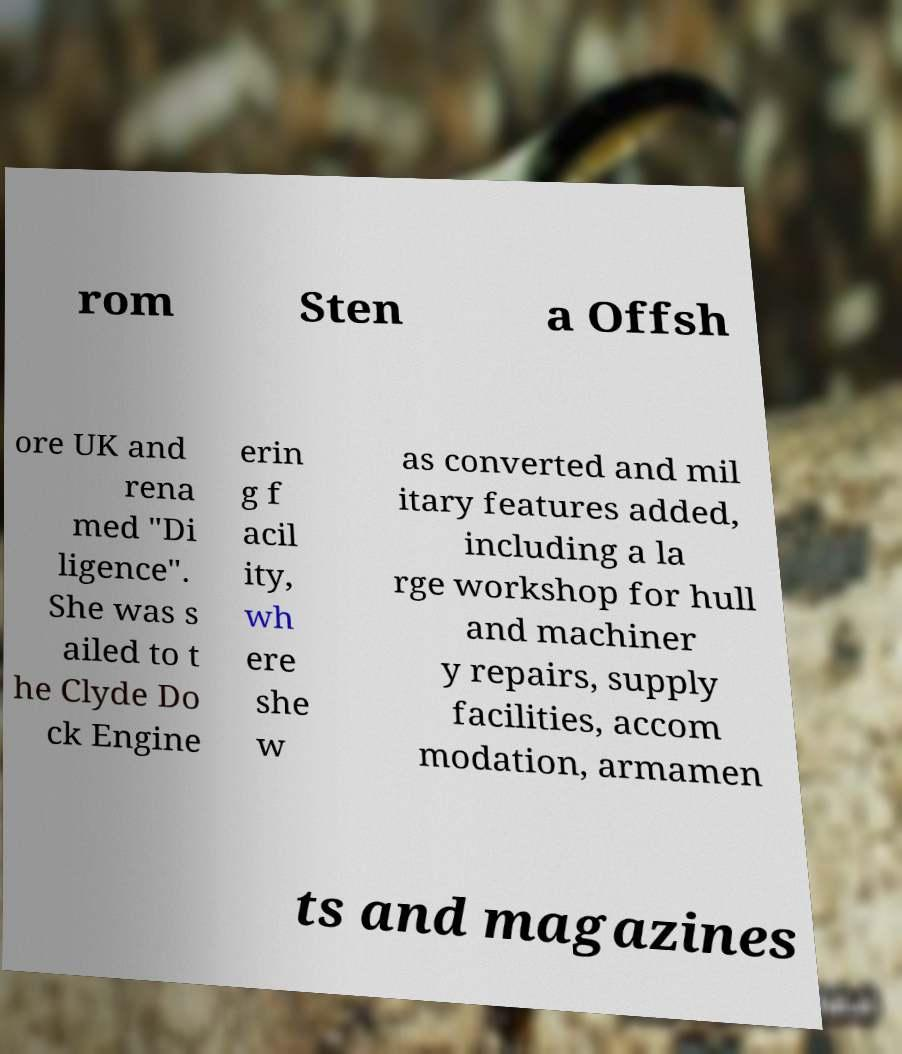Could you assist in decoding the text presented in this image and type it out clearly? rom Sten a Offsh ore UK and rena med "Di ligence". She was s ailed to t he Clyde Do ck Engine erin g f acil ity, wh ere she w as converted and mil itary features added, including a la rge workshop for hull and machiner y repairs, supply facilities, accom modation, armamen ts and magazines 